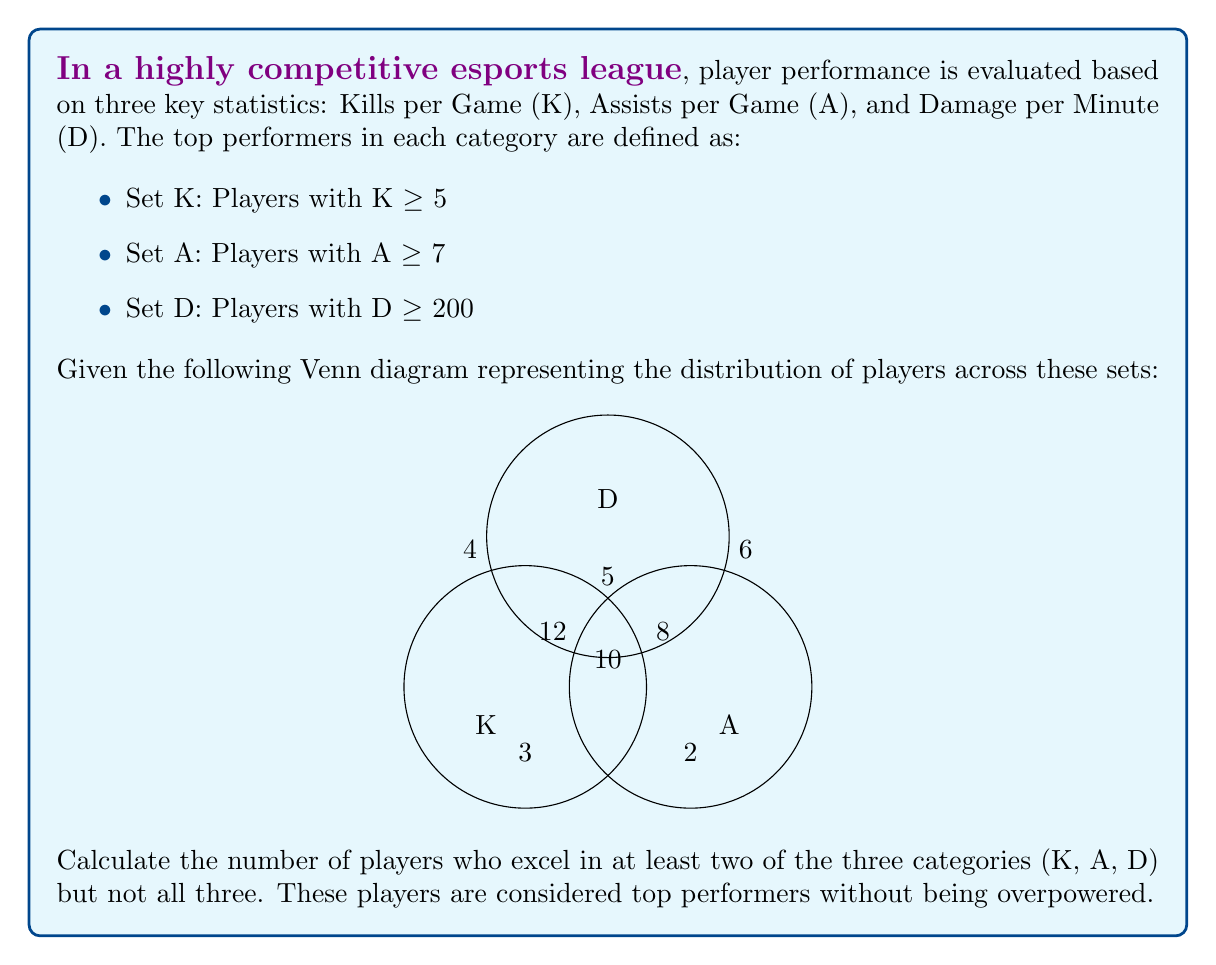Solve this math problem. To solve this problem, we need to use set theory concepts, particularly the principle of inclusion-exclusion. Let's break it down step-by-step:

1) We're looking for players who are in at least two sets but not in all three. This can be represented as:

   $$(K \cap A) \cup (K \cap D) \cup (A \cap D) - (K \cap A \cap D)$$

2) From the Venn diagram:
   - $|K \cap A| = 10$
   - $|K \cap D| = 5$
   - $|A \cap D| = 5$
   - $|K \cap A \cap D| = 10$

3) Now, let's apply the formula:

   $$(|K \cap A| + |K \cap D| + |A \cap D|) - |K \cap A \cap D|$$

4) Substituting the values:

   $$(10 + 5 + 5) - 10 = 20 - 10 = 10$$

Therefore, there are 10 players who excel in at least two categories but not all three.

This approach aligns with the competitive player persona, as it identifies top performers who have a balanced skill set without dominating all aspects of the game, promoting fair competition.
Answer: 10 players 